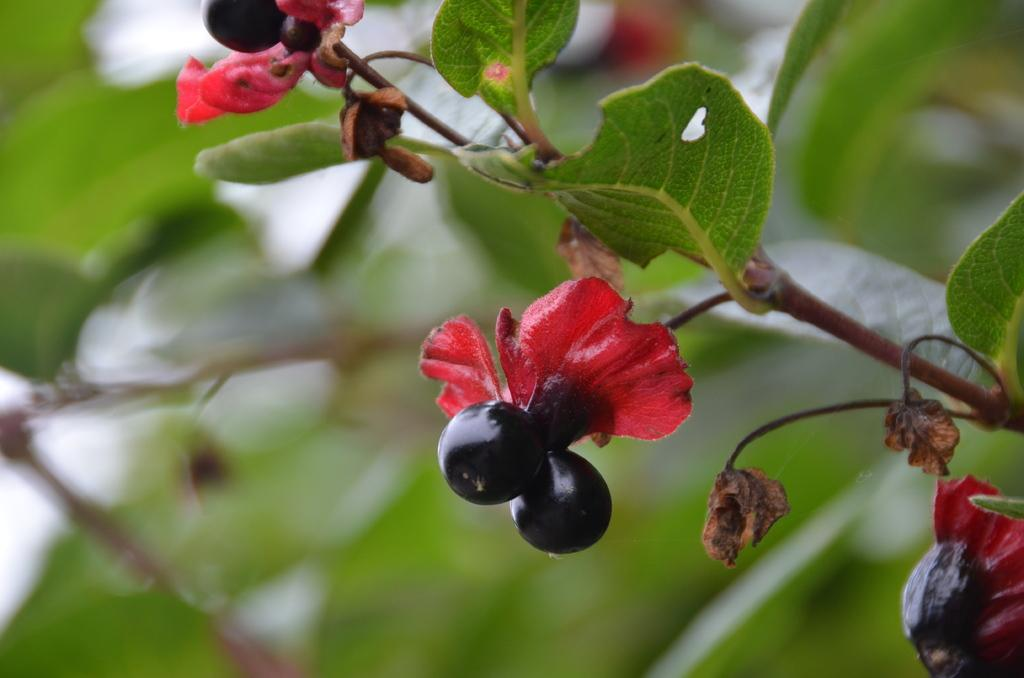What type of food items can be seen in the image? There are fruits in the image. What part of a plant is visible in the image? There are leaves of a plant in the image. What can be seen in the background of the image? There are leaves in the background of the image. How many legs can be seen supporting the throne in the image? There is no throne present in the image, so it is not possible to determine the number of legs supporting it. 